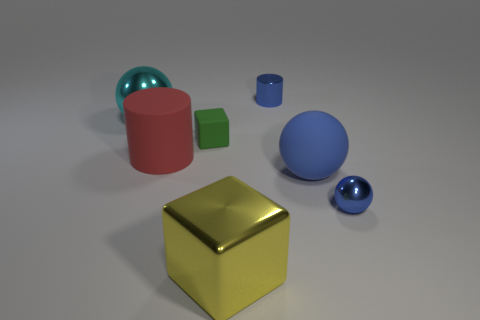Subtract all tiny balls. How many balls are left? 2 Add 1 blue shiny cylinders. How many objects exist? 8 Subtract all cyan spheres. How many spheres are left? 2 Subtract all blue cylinders. Subtract all tiny blue metal cylinders. How many objects are left? 5 Add 4 big yellow blocks. How many big yellow blocks are left? 5 Add 6 big yellow objects. How many big yellow objects exist? 7 Subtract 0 gray balls. How many objects are left? 7 Subtract all balls. How many objects are left? 4 Subtract 1 cylinders. How many cylinders are left? 1 Subtract all purple cylinders. Subtract all yellow balls. How many cylinders are left? 2 